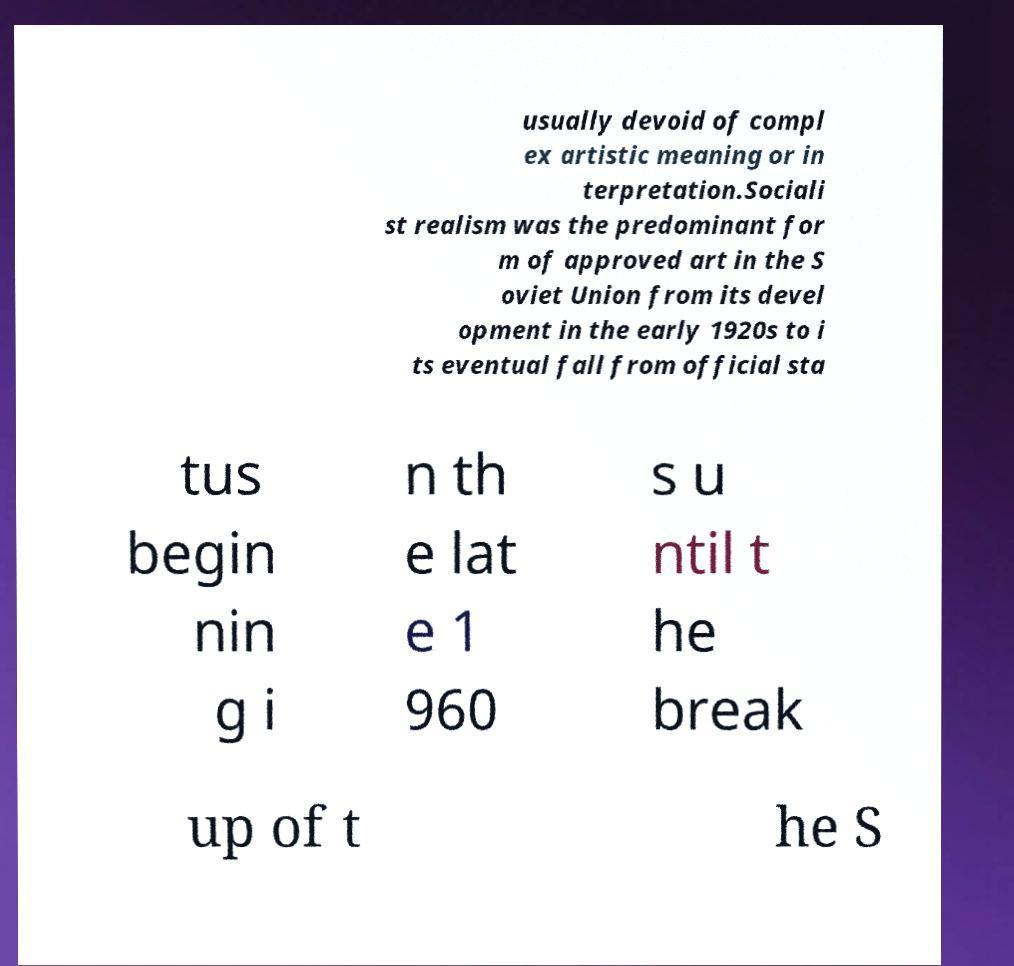Could you assist in decoding the text presented in this image and type it out clearly? usually devoid of compl ex artistic meaning or in terpretation.Sociali st realism was the predominant for m of approved art in the S oviet Union from its devel opment in the early 1920s to i ts eventual fall from official sta tus begin nin g i n th e lat e 1 960 s u ntil t he break up of t he S 